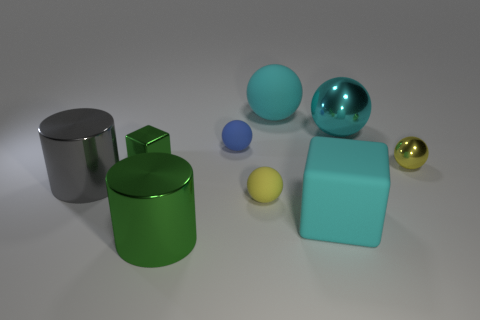What is the shape of the green object that is the same size as the gray metallic object?
Make the answer very short. Cylinder. Is there anything else that has the same size as the green metal cube?
Your response must be concise. Yes. There is a cyan thing in front of the yellow shiny object behind the small yellow rubber object; what is its material?
Your answer should be compact. Rubber. Does the green metal cylinder have the same size as the green cube?
Your answer should be compact. No. What number of things are green metallic things that are in front of the small yellow rubber object or cyan balls?
Provide a succinct answer. 3. What shape is the large object behind the large metal thing right of the green cylinder?
Offer a terse response. Sphere. Does the gray metal thing have the same size as the yellow thing behind the gray cylinder?
Your answer should be very brief. No. There is a sphere that is in front of the gray metal cylinder; what is it made of?
Provide a short and direct response. Rubber. What number of things are both on the right side of the big green metallic cylinder and in front of the tiny yellow shiny object?
Offer a terse response. 2. There is a cyan block that is the same size as the gray metal cylinder; what is its material?
Offer a terse response. Rubber. 